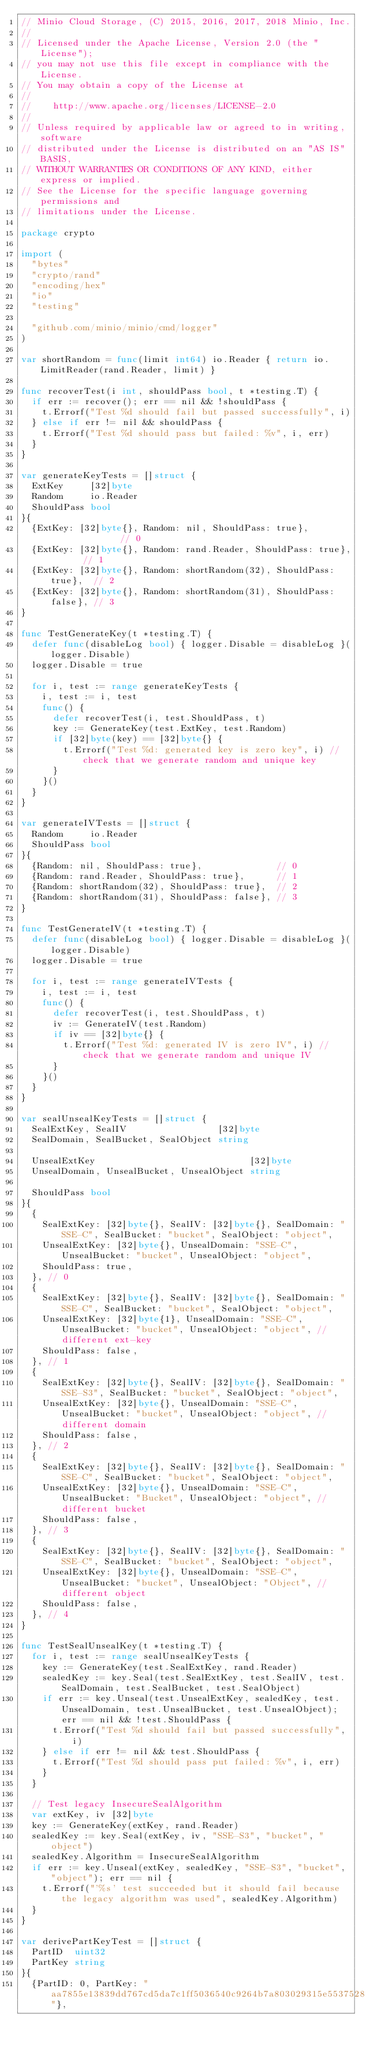Convert code to text. <code><loc_0><loc_0><loc_500><loc_500><_Go_>// Minio Cloud Storage, (C) 2015, 2016, 2017, 2018 Minio, Inc.
//
// Licensed under the Apache License, Version 2.0 (the "License");
// you may not use this file except in compliance with the License.
// You may obtain a copy of the License at
//
//    http://www.apache.org/licenses/LICENSE-2.0
//
// Unless required by applicable law or agreed to in writing, software
// distributed under the License is distributed on an "AS IS" BASIS,
// WITHOUT WARRANTIES OR CONDITIONS OF ANY KIND, either express or implied.
// See the License for the specific language governing permissions and
// limitations under the License.

package crypto

import (
	"bytes"
	"crypto/rand"
	"encoding/hex"
	"io"
	"testing"

	"github.com/minio/minio/cmd/logger"
)

var shortRandom = func(limit int64) io.Reader { return io.LimitReader(rand.Reader, limit) }

func recoverTest(i int, shouldPass bool, t *testing.T) {
	if err := recover(); err == nil && !shouldPass {
		t.Errorf("Test %d should fail but passed successfully", i)
	} else if err != nil && shouldPass {
		t.Errorf("Test %d should pass but failed: %v", i, err)
	}
}

var generateKeyTests = []struct {
	ExtKey     [32]byte
	Random     io.Reader
	ShouldPass bool
}{
	{ExtKey: [32]byte{}, Random: nil, ShouldPass: true},              // 0
	{ExtKey: [32]byte{}, Random: rand.Reader, ShouldPass: true},      // 1
	{ExtKey: [32]byte{}, Random: shortRandom(32), ShouldPass: true},  // 2
	{ExtKey: [32]byte{}, Random: shortRandom(31), ShouldPass: false}, // 3
}

func TestGenerateKey(t *testing.T) {
	defer func(disableLog bool) { logger.Disable = disableLog }(logger.Disable)
	logger.Disable = true

	for i, test := range generateKeyTests {
		i, test := i, test
		func() {
			defer recoverTest(i, test.ShouldPass, t)
			key := GenerateKey(test.ExtKey, test.Random)
			if [32]byte(key) == [32]byte{} {
				t.Errorf("Test %d: generated key is zero key", i) // check that we generate random and unique key
			}
		}()
	}
}

var generateIVTests = []struct {
	Random     io.Reader
	ShouldPass bool
}{
	{Random: nil, ShouldPass: true},              // 0
	{Random: rand.Reader, ShouldPass: true},      // 1
	{Random: shortRandom(32), ShouldPass: true},  // 2
	{Random: shortRandom(31), ShouldPass: false}, // 3
}

func TestGenerateIV(t *testing.T) {
	defer func(disableLog bool) { logger.Disable = disableLog }(logger.Disable)
	logger.Disable = true

	for i, test := range generateIVTests {
		i, test := i, test
		func() {
			defer recoverTest(i, test.ShouldPass, t)
			iv := GenerateIV(test.Random)
			if iv == [32]byte{} {
				t.Errorf("Test %d: generated IV is zero IV", i) // check that we generate random and unique IV
			}
		}()
	}
}

var sealUnsealKeyTests = []struct {
	SealExtKey, SealIV                 [32]byte
	SealDomain, SealBucket, SealObject string

	UnsealExtKey                             [32]byte
	UnsealDomain, UnsealBucket, UnsealObject string

	ShouldPass bool
}{
	{
		SealExtKey: [32]byte{}, SealIV: [32]byte{}, SealDomain: "SSE-C", SealBucket: "bucket", SealObject: "object",
		UnsealExtKey: [32]byte{}, UnsealDomain: "SSE-C", UnsealBucket: "bucket", UnsealObject: "object",
		ShouldPass: true,
	}, // 0
	{
		SealExtKey: [32]byte{}, SealIV: [32]byte{}, SealDomain: "SSE-C", SealBucket: "bucket", SealObject: "object",
		UnsealExtKey: [32]byte{1}, UnsealDomain: "SSE-C", UnsealBucket: "bucket", UnsealObject: "object", // different ext-key
		ShouldPass: false,
	}, // 1
	{
		SealExtKey: [32]byte{}, SealIV: [32]byte{}, SealDomain: "SSE-S3", SealBucket: "bucket", SealObject: "object",
		UnsealExtKey: [32]byte{}, UnsealDomain: "SSE-C", UnsealBucket: "bucket", UnsealObject: "object", // different domain
		ShouldPass: false,
	}, // 2
	{
		SealExtKey: [32]byte{}, SealIV: [32]byte{}, SealDomain: "SSE-C", SealBucket: "bucket", SealObject: "object",
		UnsealExtKey: [32]byte{}, UnsealDomain: "SSE-C", UnsealBucket: "Bucket", UnsealObject: "object", // different bucket
		ShouldPass: false,
	}, // 3
	{
		SealExtKey: [32]byte{}, SealIV: [32]byte{}, SealDomain: "SSE-C", SealBucket: "bucket", SealObject: "object",
		UnsealExtKey: [32]byte{}, UnsealDomain: "SSE-C", UnsealBucket: "bucket", UnsealObject: "Object", // different object
		ShouldPass: false,
	}, // 4
}

func TestSealUnsealKey(t *testing.T) {
	for i, test := range sealUnsealKeyTests {
		key := GenerateKey(test.SealExtKey, rand.Reader)
		sealedKey := key.Seal(test.SealExtKey, test.SealIV, test.SealDomain, test.SealBucket, test.SealObject)
		if err := key.Unseal(test.UnsealExtKey, sealedKey, test.UnsealDomain, test.UnsealBucket, test.UnsealObject); err == nil && !test.ShouldPass {
			t.Errorf("Test %d should fail but passed successfully", i)
		} else if err != nil && test.ShouldPass {
			t.Errorf("Test %d should pass put failed: %v", i, err)
		}
	}

	// Test legacy InsecureSealAlgorithm
	var extKey, iv [32]byte
	key := GenerateKey(extKey, rand.Reader)
	sealedKey := key.Seal(extKey, iv, "SSE-S3", "bucket", "object")
	sealedKey.Algorithm = InsecureSealAlgorithm
	if err := key.Unseal(extKey, sealedKey, "SSE-S3", "bucket", "object"); err == nil {
		t.Errorf("'%s' test succeeded but it should fail because the legacy algorithm was used", sealedKey.Algorithm)
	}
}

var derivePartKeyTest = []struct {
	PartID  uint32
	PartKey string
}{
	{PartID: 0, PartKey: "aa7855e13839dd767cd5da7c1ff5036540c9264b7a803029315e55375287b4af"},</code> 